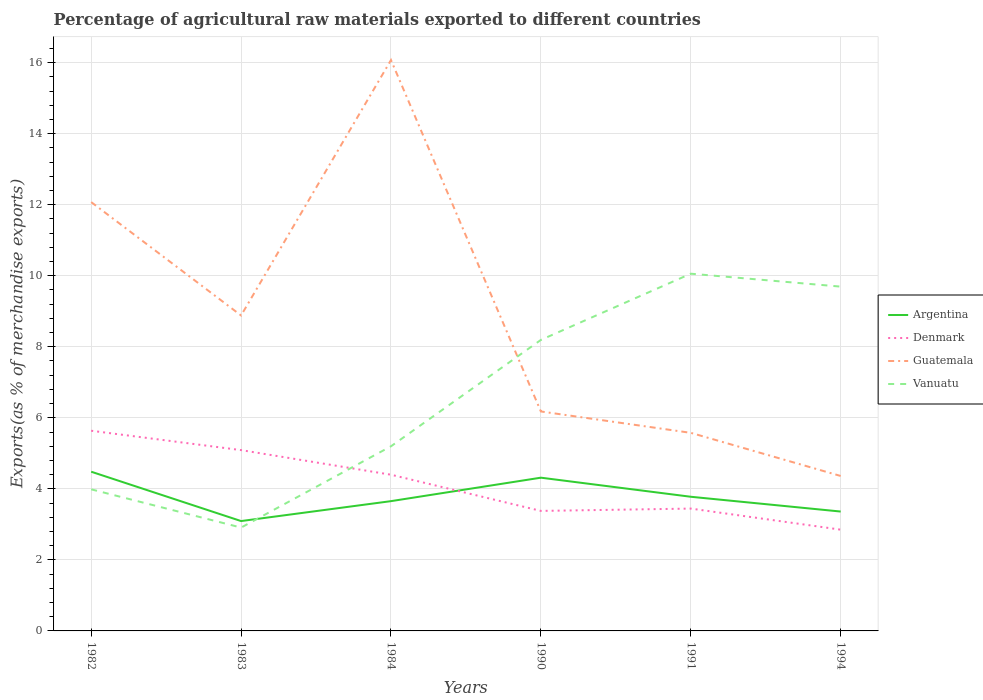How many different coloured lines are there?
Make the answer very short. 4. Does the line corresponding to Guatemala intersect with the line corresponding to Argentina?
Your answer should be very brief. No. Is the number of lines equal to the number of legend labels?
Provide a succinct answer. Yes. Across all years, what is the maximum percentage of exports to different countries in Argentina?
Your answer should be compact. 3.09. What is the total percentage of exports to different countries in Guatemala in the graph?
Offer a terse response. 3.19. What is the difference between the highest and the second highest percentage of exports to different countries in Vanuatu?
Your answer should be compact. 7.15. What is the difference between the highest and the lowest percentage of exports to different countries in Denmark?
Provide a succinct answer. 3. How many lines are there?
Provide a short and direct response. 4. Are the values on the major ticks of Y-axis written in scientific E-notation?
Ensure brevity in your answer.  No. Does the graph contain any zero values?
Offer a very short reply. No. How many legend labels are there?
Provide a short and direct response. 4. How are the legend labels stacked?
Give a very brief answer. Vertical. What is the title of the graph?
Make the answer very short. Percentage of agricultural raw materials exported to different countries. Does "Timor-Leste" appear as one of the legend labels in the graph?
Make the answer very short. No. What is the label or title of the Y-axis?
Provide a succinct answer. Exports(as % of merchandise exports). What is the Exports(as % of merchandise exports) of Argentina in 1982?
Offer a very short reply. 4.48. What is the Exports(as % of merchandise exports) of Denmark in 1982?
Offer a terse response. 5.64. What is the Exports(as % of merchandise exports) in Guatemala in 1982?
Offer a very short reply. 12.07. What is the Exports(as % of merchandise exports) in Vanuatu in 1982?
Provide a succinct answer. 3.99. What is the Exports(as % of merchandise exports) of Argentina in 1983?
Keep it short and to the point. 3.09. What is the Exports(as % of merchandise exports) in Denmark in 1983?
Your answer should be compact. 5.09. What is the Exports(as % of merchandise exports) in Guatemala in 1983?
Your response must be concise. 8.88. What is the Exports(as % of merchandise exports) in Vanuatu in 1983?
Make the answer very short. 2.91. What is the Exports(as % of merchandise exports) in Argentina in 1984?
Make the answer very short. 3.65. What is the Exports(as % of merchandise exports) in Denmark in 1984?
Your response must be concise. 4.4. What is the Exports(as % of merchandise exports) of Guatemala in 1984?
Your answer should be compact. 16.07. What is the Exports(as % of merchandise exports) of Vanuatu in 1984?
Keep it short and to the point. 5.2. What is the Exports(as % of merchandise exports) of Argentina in 1990?
Give a very brief answer. 4.31. What is the Exports(as % of merchandise exports) in Denmark in 1990?
Your answer should be compact. 3.38. What is the Exports(as % of merchandise exports) of Guatemala in 1990?
Your answer should be very brief. 6.18. What is the Exports(as % of merchandise exports) of Vanuatu in 1990?
Your answer should be very brief. 8.19. What is the Exports(as % of merchandise exports) in Argentina in 1991?
Offer a terse response. 3.78. What is the Exports(as % of merchandise exports) of Denmark in 1991?
Give a very brief answer. 3.44. What is the Exports(as % of merchandise exports) of Guatemala in 1991?
Offer a terse response. 5.58. What is the Exports(as % of merchandise exports) in Vanuatu in 1991?
Your response must be concise. 10.06. What is the Exports(as % of merchandise exports) of Argentina in 1994?
Offer a terse response. 3.36. What is the Exports(as % of merchandise exports) in Denmark in 1994?
Offer a very short reply. 2.85. What is the Exports(as % of merchandise exports) in Guatemala in 1994?
Keep it short and to the point. 4.36. What is the Exports(as % of merchandise exports) of Vanuatu in 1994?
Your answer should be compact. 9.69. Across all years, what is the maximum Exports(as % of merchandise exports) in Argentina?
Your answer should be very brief. 4.48. Across all years, what is the maximum Exports(as % of merchandise exports) of Denmark?
Offer a terse response. 5.64. Across all years, what is the maximum Exports(as % of merchandise exports) of Guatemala?
Keep it short and to the point. 16.07. Across all years, what is the maximum Exports(as % of merchandise exports) of Vanuatu?
Your answer should be very brief. 10.06. Across all years, what is the minimum Exports(as % of merchandise exports) of Argentina?
Keep it short and to the point. 3.09. Across all years, what is the minimum Exports(as % of merchandise exports) of Denmark?
Ensure brevity in your answer.  2.85. Across all years, what is the minimum Exports(as % of merchandise exports) of Guatemala?
Make the answer very short. 4.36. Across all years, what is the minimum Exports(as % of merchandise exports) in Vanuatu?
Provide a succinct answer. 2.91. What is the total Exports(as % of merchandise exports) in Argentina in the graph?
Your response must be concise. 22.68. What is the total Exports(as % of merchandise exports) in Denmark in the graph?
Provide a short and direct response. 24.8. What is the total Exports(as % of merchandise exports) of Guatemala in the graph?
Your response must be concise. 53.14. What is the total Exports(as % of merchandise exports) of Vanuatu in the graph?
Give a very brief answer. 40.04. What is the difference between the Exports(as % of merchandise exports) in Argentina in 1982 and that in 1983?
Your answer should be compact. 1.39. What is the difference between the Exports(as % of merchandise exports) in Denmark in 1982 and that in 1983?
Provide a succinct answer. 0.55. What is the difference between the Exports(as % of merchandise exports) in Guatemala in 1982 and that in 1983?
Provide a short and direct response. 3.19. What is the difference between the Exports(as % of merchandise exports) of Vanuatu in 1982 and that in 1983?
Your answer should be very brief. 1.08. What is the difference between the Exports(as % of merchandise exports) of Argentina in 1982 and that in 1984?
Ensure brevity in your answer.  0.83. What is the difference between the Exports(as % of merchandise exports) in Denmark in 1982 and that in 1984?
Provide a succinct answer. 1.24. What is the difference between the Exports(as % of merchandise exports) of Guatemala in 1982 and that in 1984?
Your response must be concise. -4. What is the difference between the Exports(as % of merchandise exports) in Vanuatu in 1982 and that in 1984?
Keep it short and to the point. -1.21. What is the difference between the Exports(as % of merchandise exports) of Argentina in 1982 and that in 1990?
Keep it short and to the point. 0.17. What is the difference between the Exports(as % of merchandise exports) in Denmark in 1982 and that in 1990?
Keep it short and to the point. 2.26. What is the difference between the Exports(as % of merchandise exports) of Guatemala in 1982 and that in 1990?
Your answer should be very brief. 5.89. What is the difference between the Exports(as % of merchandise exports) of Vanuatu in 1982 and that in 1990?
Your answer should be very brief. -4.21. What is the difference between the Exports(as % of merchandise exports) of Argentina in 1982 and that in 1991?
Give a very brief answer. 0.71. What is the difference between the Exports(as % of merchandise exports) in Denmark in 1982 and that in 1991?
Keep it short and to the point. 2.19. What is the difference between the Exports(as % of merchandise exports) in Guatemala in 1982 and that in 1991?
Your answer should be compact. 6.5. What is the difference between the Exports(as % of merchandise exports) in Vanuatu in 1982 and that in 1991?
Provide a succinct answer. -6.07. What is the difference between the Exports(as % of merchandise exports) of Argentina in 1982 and that in 1994?
Provide a short and direct response. 1.12. What is the difference between the Exports(as % of merchandise exports) in Denmark in 1982 and that in 1994?
Your answer should be compact. 2.79. What is the difference between the Exports(as % of merchandise exports) of Guatemala in 1982 and that in 1994?
Your answer should be compact. 7.71. What is the difference between the Exports(as % of merchandise exports) of Vanuatu in 1982 and that in 1994?
Offer a terse response. -5.71. What is the difference between the Exports(as % of merchandise exports) of Argentina in 1983 and that in 1984?
Provide a succinct answer. -0.56. What is the difference between the Exports(as % of merchandise exports) of Denmark in 1983 and that in 1984?
Ensure brevity in your answer.  0.69. What is the difference between the Exports(as % of merchandise exports) of Guatemala in 1983 and that in 1984?
Provide a succinct answer. -7.19. What is the difference between the Exports(as % of merchandise exports) of Vanuatu in 1983 and that in 1984?
Provide a short and direct response. -2.29. What is the difference between the Exports(as % of merchandise exports) in Argentina in 1983 and that in 1990?
Your response must be concise. -1.22. What is the difference between the Exports(as % of merchandise exports) of Denmark in 1983 and that in 1990?
Your answer should be compact. 1.71. What is the difference between the Exports(as % of merchandise exports) of Guatemala in 1983 and that in 1990?
Your answer should be compact. 2.7. What is the difference between the Exports(as % of merchandise exports) of Vanuatu in 1983 and that in 1990?
Your response must be concise. -5.28. What is the difference between the Exports(as % of merchandise exports) in Argentina in 1983 and that in 1991?
Your response must be concise. -0.68. What is the difference between the Exports(as % of merchandise exports) in Denmark in 1983 and that in 1991?
Make the answer very short. 1.65. What is the difference between the Exports(as % of merchandise exports) of Guatemala in 1983 and that in 1991?
Keep it short and to the point. 3.3. What is the difference between the Exports(as % of merchandise exports) of Vanuatu in 1983 and that in 1991?
Make the answer very short. -7.15. What is the difference between the Exports(as % of merchandise exports) of Argentina in 1983 and that in 1994?
Your response must be concise. -0.27. What is the difference between the Exports(as % of merchandise exports) in Denmark in 1983 and that in 1994?
Offer a very short reply. 2.24. What is the difference between the Exports(as % of merchandise exports) in Guatemala in 1983 and that in 1994?
Make the answer very short. 4.52. What is the difference between the Exports(as % of merchandise exports) of Vanuatu in 1983 and that in 1994?
Your response must be concise. -6.78. What is the difference between the Exports(as % of merchandise exports) of Argentina in 1984 and that in 1990?
Provide a succinct answer. -0.66. What is the difference between the Exports(as % of merchandise exports) of Denmark in 1984 and that in 1990?
Offer a very short reply. 1.02. What is the difference between the Exports(as % of merchandise exports) in Guatemala in 1984 and that in 1990?
Provide a succinct answer. 9.89. What is the difference between the Exports(as % of merchandise exports) in Vanuatu in 1984 and that in 1990?
Provide a succinct answer. -2.99. What is the difference between the Exports(as % of merchandise exports) of Argentina in 1984 and that in 1991?
Your response must be concise. -0.12. What is the difference between the Exports(as % of merchandise exports) in Denmark in 1984 and that in 1991?
Offer a very short reply. 0.95. What is the difference between the Exports(as % of merchandise exports) in Guatemala in 1984 and that in 1991?
Your answer should be compact. 10.49. What is the difference between the Exports(as % of merchandise exports) of Vanuatu in 1984 and that in 1991?
Provide a short and direct response. -4.86. What is the difference between the Exports(as % of merchandise exports) in Argentina in 1984 and that in 1994?
Offer a terse response. 0.29. What is the difference between the Exports(as % of merchandise exports) in Denmark in 1984 and that in 1994?
Provide a short and direct response. 1.55. What is the difference between the Exports(as % of merchandise exports) of Guatemala in 1984 and that in 1994?
Make the answer very short. 11.71. What is the difference between the Exports(as % of merchandise exports) of Vanuatu in 1984 and that in 1994?
Ensure brevity in your answer.  -4.5. What is the difference between the Exports(as % of merchandise exports) in Argentina in 1990 and that in 1991?
Keep it short and to the point. 0.54. What is the difference between the Exports(as % of merchandise exports) of Denmark in 1990 and that in 1991?
Keep it short and to the point. -0.07. What is the difference between the Exports(as % of merchandise exports) in Guatemala in 1990 and that in 1991?
Provide a short and direct response. 0.6. What is the difference between the Exports(as % of merchandise exports) of Vanuatu in 1990 and that in 1991?
Offer a terse response. -1.86. What is the difference between the Exports(as % of merchandise exports) in Argentina in 1990 and that in 1994?
Your response must be concise. 0.95. What is the difference between the Exports(as % of merchandise exports) in Denmark in 1990 and that in 1994?
Ensure brevity in your answer.  0.53. What is the difference between the Exports(as % of merchandise exports) of Guatemala in 1990 and that in 1994?
Your answer should be compact. 1.82. What is the difference between the Exports(as % of merchandise exports) of Vanuatu in 1990 and that in 1994?
Ensure brevity in your answer.  -1.5. What is the difference between the Exports(as % of merchandise exports) in Argentina in 1991 and that in 1994?
Provide a succinct answer. 0.42. What is the difference between the Exports(as % of merchandise exports) in Denmark in 1991 and that in 1994?
Give a very brief answer. 0.59. What is the difference between the Exports(as % of merchandise exports) in Guatemala in 1991 and that in 1994?
Provide a succinct answer. 1.21. What is the difference between the Exports(as % of merchandise exports) in Vanuatu in 1991 and that in 1994?
Provide a succinct answer. 0.36. What is the difference between the Exports(as % of merchandise exports) in Argentina in 1982 and the Exports(as % of merchandise exports) in Denmark in 1983?
Give a very brief answer. -0.61. What is the difference between the Exports(as % of merchandise exports) in Argentina in 1982 and the Exports(as % of merchandise exports) in Guatemala in 1983?
Keep it short and to the point. -4.4. What is the difference between the Exports(as % of merchandise exports) of Argentina in 1982 and the Exports(as % of merchandise exports) of Vanuatu in 1983?
Make the answer very short. 1.57. What is the difference between the Exports(as % of merchandise exports) in Denmark in 1982 and the Exports(as % of merchandise exports) in Guatemala in 1983?
Keep it short and to the point. -3.25. What is the difference between the Exports(as % of merchandise exports) of Denmark in 1982 and the Exports(as % of merchandise exports) of Vanuatu in 1983?
Your answer should be very brief. 2.73. What is the difference between the Exports(as % of merchandise exports) of Guatemala in 1982 and the Exports(as % of merchandise exports) of Vanuatu in 1983?
Your answer should be very brief. 9.16. What is the difference between the Exports(as % of merchandise exports) in Argentina in 1982 and the Exports(as % of merchandise exports) in Denmark in 1984?
Ensure brevity in your answer.  0.08. What is the difference between the Exports(as % of merchandise exports) of Argentina in 1982 and the Exports(as % of merchandise exports) of Guatemala in 1984?
Give a very brief answer. -11.59. What is the difference between the Exports(as % of merchandise exports) of Argentina in 1982 and the Exports(as % of merchandise exports) of Vanuatu in 1984?
Provide a succinct answer. -0.72. What is the difference between the Exports(as % of merchandise exports) in Denmark in 1982 and the Exports(as % of merchandise exports) in Guatemala in 1984?
Give a very brief answer. -10.44. What is the difference between the Exports(as % of merchandise exports) of Denmark in 1982 and the Exports(as % of merchandise exports) of Vanuatu in 1984?
Offer a very short reply. 0.44. What is the difference between the Exports(as % of merchandise exports) in Guatemala in 1982 and the Exports(as % of merchandise exports) in Vanuatu in 1984?
Give a very brief answer. 6.87. What is the difference between the Exports(as % of merchandise exports) of Argentina in 1982 and the Exports(as % of merchandise exports) of Denmark in 1990?
Provide a short and direct response. 1.1. What is the difference between the Exports(as % of merchandise exports) of Argentina in 1982 and the Exports(as % of merchandise exports) of Guatemala in 1990?
Your response must be concise. -1.7. What is the difference between the Exports(as % of merchandise exports) in Argentina in 1982 and the Exports(as % of merchandise exports) in Vanuatu in 1990?
Provide a succinct answer. -3.71. What is the difference between the Exports(as % of merchandise exports) in Denmark in 1982 and the Exports(as % of merchandise exports) in Guatemala in 1990?
Keep it short and to the point. -0.54. What is the difference between the Exports(as % of merchandise exports) of Denmark in 1982 and the Exports(as % of merchandise exports) of Vanuatu in 1990?
Give a very brief answer. -2.56. What is the difference between the Exports(as % of merchandise exports) of Guatemala in 1982 and the Exports(as % of merchandise exports) of Vanuatu in 1990?
Give a very brief answer. 3.88. What is the difference between the Exports(as % of merchandise exports) in Argentina in 1982 and the Exports(as % of merchandise exports) in Denmark in 1991?
Keep it short and to the point. 1.04. What is the difference between the Exports(as % of merchandise exports) in Argentina in 1982 and the Exports(as % of merchandise exports) in Guatemala in 1991?
Your answer should be very brief. -1.09. What is the difference between the Exports(as % of merchandise exports) in Argentina in 1982 and the Exports(as % of merchandise exports) in Vanuatu in 1991?
Your answer should be compact. -5.57. What is the difference between the Exports(as % of merchandise exports) in Denmark in 1982 and the Exports(as % of merchandise exports) in Guatemala in 1991?
Make the answer very short. 0.06. What is the difference between the Exports(as % of merchandise exports) in Denmark in 1982 and the Exports(as % of merchandise exports) in Vanuatu in 1991?
Your answer should be very brief. -4.42. What is the difference between the Exports(as % of merchandise exports) of Guatemala in 1982 and the Exports(as % of merchandise exports) of Vanuatu in 1991?
Provide a short and direct response. 2.02. What is the difference between the Exports(as % of merchandise exports) in Argentina in 1982 and the Exports(as % of merchandise exports) in Denmark in 1994?
Ensure brevity in your answer.  1.63. What is the difference between the Exports(as % of merchandise exports) in Argentina in 1982 and the Exports(as % of merchandise exports) in Guatemala in 1994?
Your answer should be compact. 0.12. What is the difference between the Exports(as % of merchandise exports) of Argentina in 1982 and the Exports(as % of merchandise exports) of Vanuatu in 1994?
Your response must be concise. -5.21. What is the difference between the Exports(as % of merchandise exports) of Denmark in 1982 and the Exports(as % of merchandise exports) of Guatemala in 1994?
Your response must be concise. 1.27. What is the difference between the Exports(as % of merchandise exports) in Denmark in 1982 and the Exports(as % of merchandise exports) in Vanuatu in 1994?
Your answer should be very brief. -4.06. What is the difference between the Exports(as % of merchandise exports) in Guatemala in 1982 and the Exports(as % of merchandise exports) in Vanuatu in 1994?
Offer a very short reply. 2.38. What is the difference between the Exports(as % of merchandise exports) in Argentina in 1983 and the Exports(as % of merchandise exports) in Denmark in 1984?
Your answer should be very brief. -1.3. What is the difference between the Exports(as % of merchandise exports) in Argentina in 1983 and the Exports(as % of merchandise exports) in Guatemala in 1984?
Offer a very short reply. -12.98. What is the difference between the Exports(as % of merchandise exports) in Argentina in 1983 and the Exports(as % of merchandise exports) in Vanuatu in 1984?
Ensure brevity in your answer.  -2.1. What is the difference between the Exports(as % of merchandise exports) in Denmark in 1983 and the Exports(as % of merchandise exports) in Guatemala in 1984?
Provide a short and direct response. -10.98. What is the difference between the Exports(as % of merchandise exports) in Denmark in 1983 and the Exports(as % of merchandise exports) in Vanuatu in 1984?
Give a very brief answer. -0.11. What is the difference between the Exports(as % of merchandise exports) in Guatemala in 1983 and the Exports(as % of merchandise exports) in Vanuatu in 1984?
Make the answer very short. 3.68. What is the difference between the Exports(as % of merchandise exports) in Argentina in 1983 and the Exports(as % of merchandise exports) in Denmark in 1990?
Offer a very short reply. -0.29. What is the difference between the Exports(as % of merchandise exports) of Argentina in 1983 and the Exports(as % of merchandise exports) of Guatemala in 1990?
Keep it short and to the point. -3.09. What is the difference between the Exports(as % of merchandise exports) in Argentina in 1983 and the Exports(as % of merchandise exports) in Vanuatu in 1990?
Provide a short and direct response. -5.1. What is the difference between the Exports(as % of merchandise exports) of Denmark in 1983 and the Exports(as % of merchandise exports) of Guatemala in 1990?
Your answer should be compact. -1.09. What is the difference between the Exports(as % of merchandise exports) in Denmark in 1983 and the Exports(as % of merchandise exports) in Vanuatu in 1990?
Offer a terse response. -3.1. What is the difference between the Exports(as % of merchandise exports) in Guatemala in 1983 and the Exports(as % of merchandise exports) in Vanuatu in 1990?
Keep it short and to the point. 0.69. What is the difference between the Exports(as % of merchandise exports) in Argentina in 1983 and the Exports(as % of merchandise exports) in Denmark in 1991?
Provide a short and direct response. -0.35. What is the difference between the Exports(as % of merchandise exports) in Argentina in 1983 and the Exports(as % of merchandise exports) in Guatemala in 1991?
Keep it short and to the point. -2.48. What is the difference between the Exports(as % of merchandise exports) in Argentina in 1983 and the Exports(as % of merchandise exports) in Vanuatu in 1991?
Your answer should be very brief. -6.96. What is the difference between the Exports(as % of merchandise exports) of Denmark in 1983 and the Exports(as % of merchandise exports) of Guatemala in 1991?
Provide a succinct answer. -0.49. What is the difference between the Exports(as % of merchandise exports) in Denmark in 1983 and the Exports(as % of merchandise exports) in Vanuatu in 1991?
Ensure brevity in your answer.  -4.97. What is the difference between the Exports(as % of merchandise exports) in Guatemala in 1983 and the Exports(as % of merchandise exports) in Vanuatu in 1991?
Your response must be concise. -1.18. What is the difference between the Exports(as % of merchandise exports) in Argentina in 1983 and the Exports(as % of merchandise exports) in Denmark in 1994?
Keep it short and to the point. 0.24. What is the difference between the Exports(as % of merchandise exports) of Argentina in 1983 and the Exports(as % of merchandise exports) of Guatemala in 1994?
Offer a very short reply. -1.27. What is the difference between the Exports(as % of merchandise exports) in Argentina in 1983 and the Exports(as % of merchandise exports) in Vanuatu in 1994?
Offer a very short reply. -6.6. What is the difference between the Exports(as % of merchandise exports) of Denmark in 1983 and the Exports(as % of merchandise exports) of Guatemala in 1994?
Provide a succinct answer. 0.73. What is the difference between the Exports(as % of merchandise exports) in Denmark in 1983 and the Exports(as % of merchandise exports) in Vanuatu in 1994?
Offer a terse response. -4.6. What is the difference between the Exports(as % of merchandise exports) of Guatemala in 1983 and the Exports(as % of merchandise exports) of Vanuatu in 1994?
Your response must be concise. -0.81. What is the difference between the Exports(as % of merchandise exports) of Argentina in 1984 and the Exports(as % of merchandise exports) of Denmark in 1990?
Give a very brief answer. 0.28. What is the difference between the Exports(as % of merchandise exports) in Argentina in 1984 and the Exports(as % of merchandise exports) in Guatemala in 1990?
Offer a terse response. -2.52. What is the difference between the Exports(as % of merchandise exports) of Argentina in 1984 and the Exports(as % of merchandise exports) of Vanuatu in 1990?
Offer a very short reply. -4.54. What is the difference between the Exports(as % of merchandise exports) in Denmark in 1984 and the Exports(as % of merchandise exports) in Guatemala in 1990?
Give a very brief answer. -1.78. What is the difference between the Exports(as % of merchandise exports) in Denmark in 1984 and the Exports(as % of merchandise exports) in Vanuatu in 1990?
Your answer should be compact. -3.8. What is the difference between the Exports(as % of merchandise exports) of Guatemala in 1984 and the Exports(as % of merchandise exports) of Vanuatu in 1990?
Your answer should be compact. 7.88. What is the difference between the Exports(as % of merchandise exports) in Argentina in 1984 and the Exports(as % of merchandise exports) in Denmark in 1991?
Make the answer very short. 0.21. What is the difference between the Exports(as % of merchandise exports) in Argentina in 1984 and the Exports(as % of merchandise exports) in Guatemala in 1991?
Offer a very short reply. -1.92. What is the difference between the Exports(as % of merchandise exports) in Argentina in 1984 and the Exports(as % of merchandise exports) in Vanuatu in 1991?
Your answer should be very brief. -6.4. What is the difference between the Exports(as % of merchandise exports) of Denmark in 1984 and the Exports(as % of merchandise exports) of Guatemala in 1991?
Your answer should be compact. -1.18. What is the difference between the Exports(as % of merchandise exports) in Denmark in 1984 and the Exports(as % of merchandise exports) in Vanuatu in 1991?
Offer a very short reply. -5.66. What is the difference between the Exports(as % of merchandise exports) of Guatemala in 1984 and the Exports(as % of merchandise exports) of Vanuatu in 1991?
Provide a succinct answer. 6.01. What is the difference between the Exports(as % of merchandise exports) in Argentina in 1984 and the Exports(as % of merchandise exports) in Denmark in 1994?
Provide a succinct answer. 0.8. What is the difference between the Exports(as % of merchandise exports) in Argentina in 1984 and the Exports(as % of merchandise exports) in Guatemala in 1994?
Ensure brevity in your answer.  -0.71. What is the difference between the Exports(as % of merchandise exports) in Argentina in 1984 and the Exports(as % of merchandise exports) in Vanuatu in 1994?
Provide a succinct answer. -6.04. What is the difference between the Exports(as % of merchandise exports) of Denmark in 1984 and the Exports(as % of merchandise exports) of Guatemala in 1994?
Provide a succinct answer. 0.04. What is the difference between the Exports(as % of merchandise exports) of Denmark in 1984 and the Exports(as % of merchandise exports) of Vanuatu in 1994?
Offer a terse response. -5.3. What is the difference between the Exports(as % of merchandise exports) in Guatemala in 1984 and the Exports(as % of merchandise exports) in Vanuatu in 1994?
Keep it short and to the point. 6.38. What is the difference between the Exports(as % of merchandise exports) in Argentina in 1990 and the Exports(as % of merchandise exports) in Denmark in 1991?
Keep it short and to the point. 0.87. What is the difference between the Exports(as % of merchandise exports) in Argentina in 1990 and the Exports(as % of merchandise exports) in Guatemala in 1991?
Your response must be concise. -1.26. What is the difference between the Exports(as % of merchandise exports) in Argentina in 1990 and the Exports(as % of merchandise exports) in Vanuatu in 1991?
Offer a terse response. -5.74. What is the difference between the Exports(as % of merchandise exports) of Denmark in 1990 and the Exports(as % of merchandise exports) of Guatemala in 1991?
Your answer should be very brief. -2.2. What is the difference between the Exports(as % of merchandise exports) in Denmark in 1990 and the Exports(as % of merchandise exports) in Vanuatu in 1991?
Your answer should be very brief. -6.68. What is the difference between the Exports(as % of merchandise exports) of Guatemala in 1990 and the Exports(as % of merchandise exports) of Vanuatu in 1991?
Make the answer very short. -3.88. What is the difference between the Exports(as % of merchandise exports) in Argentina in 1990 and the Exports(as % of merchandise exports) in Denmark in 1994?
Ensure brevity in your answer.  1.46. What is the difference between the Exports(as % of merchandise exports) in Argentina in 1990 and the Exports(as % of merchandise exports) in Guatemala in 1994?
Your answer should be compact. -0.05. What is the difference between the Exports(as % of merchandise exports) in Argentina in 1990 and the Exports(as % of merchandise exports) in Vanuatu in 1994?
Give a very brief answer. -5.38. What is the difference between the Exports(as % of merchandise exports) of Denmark in 1990 and the Exports(as % of merchandise exports) of Guatemala in 1994?
Provide a succinct answer. -0.98. What is the difference between the Exports(as % of merchandise exports) in Denmark in 1990 and the Exports(as % of merchandise exports) in Vanuatu in 1994?
Provide a short and direct response. -6.31. What is the difference between the Exports(as % of merchandise exports) in Guatemala in 1990 and the Exports(as % of merchandise exports) in Vanuatu in 1994?
Provide a short and direct response. -3.52. What is the difference between the Exports(as % of merchandise exports) in Argentina in 1991 and the Exports(as % of merchandise exports) in Denmark in 1994?
Offer a very short reply. 0.93. What is the difference between the Exports(as % of merchandise exports) of Argentina in 1991 and the Exports(as % of merchandise exports) of Guatemala in 1994?
Ensure brevity in your answer.  -0.59. What is the difference between the Exports(as % of merchandise exports) of Argentina in 1991 and the Exports(as % of merchandise exports) of Vanuatu in 1994?
Make the answer very short. -5.92. What is the difference between the Exports(as % of merchandise exports) of Denmark in 1991 and the Exports(as % of merchandise exports) of Guatemala in 1994?
Offer a terse response. -0.92. What is the difference between the Exports(as % of merchandise exports) in Denmark in 1991 and the Exports(as % of merchandise exports) in Vanuatu in 1994?
Offer a very short reply. -6.25. What is the difference between the Exports(as % of merchandise exports) of Guatemala in 1991 and the Exports(as % of merchandise exports) of Vanuatu in 1994?
Your answer should be very brief. -4.12. What is the average Exports(as % of merchandise exports) in Argentina per year?
Your response must be concise. 3.78. What is the average Exports(as % of merchandise exports) in Denmark per year?
Your answer should be compact. 4.13. What is the average Exports(as % of merchandise exports) in Guatemala per year?
Give a very brief answer. 8.86. What is the average Exports(as % of merchandise exports) in Vanuatu per year?
Provide a succinct answer. 6.67. In the year 1982, what is the difference between the Exports(as % of merchandise exports) of Argentina and Exports(as % of merchandise exports) of Denmark?
Make the answer very short. -1.15. In the year 1982, what is the difference between the Exports(as % of merchandise exports) of Argentina and Exports(as % of merchandise exports) of Guatemala?
Your response must be concise. -7.59. In the year 1982, what is the difference between the Exports(as % of merchandise exports) in Argentina and Exports(as % of merchandise exports) in Vanuatu?
Your response must be concise. 0.5. In the year 1982, what is the difference between the Exports(as % of merchandise exports) in Denmark and Exports(as % of merchandise exports) in Guatemala?
Your response must be concise. -6.44. In the year 1982, what is the difference between the Exports(as % of merchandise exports) in Denmark and Exports(as % of merchandise exports) in Vanuatu?
Ensure brevity in your answer.  1.65. In the year 1982, what is the difference between the Exports(as % of merchandise exports) of Guatemala and Exports(as % of merchandise exports) of Vanuatu?
Ensure brevity in your answer.  8.09. In the year 1983, what is the difference between the Exports(as % of merchandise exports) in Argentina and Exports(as % of merchandise exports) in Denmark?
Offer a very short reply. -2. In the year 1983, what is the difference between the Exports(as % of merchandise exports) in Argentina and Exports(as % of merchandise exports) in Guatemala?
Provide a short and direct response. -5.79. In the year 1983, what is the difference between the Exports(as % of merchandise exports) in Argentina and Exports(as % of merchandise exports) in Vanuatu?
Offer a terse response. 0.18. In the year 1983, what is the difference between the Exports(as % of merchandise exports) of Denmark and Exports(as % of merchandise exports) of Guatemala?
Offer a very short reply. -3.79. In the year 1983, what is the difference between the Exports(as % of merchandise exports) of Denmark and Exports(as % of merchandise exports) of Vanuatu?
Your response must be concise. 2.18. In the year 1983, what is the difference between the Exports(as % of merchandise exports) in Guatemala and Exports(as % of merchandise exports) in Vanuatu?
Provide a short and direct response. 5.97. In the year 1984, what is the difference between the Exports(as % of merchandise exports) in Argentina and Exports(as % of merchandise exports) in Denmark?
Provide a short and direct response. -0.74. In the year 1984, what is the difference between the Exports(as % of merchandise exports) of Argentina and Exports(as % of merchandise exports) of Guatemala?
Offer a very short reply. -12.42. In the year 1984, what is the difference between the Exports(as % of merchandise exports) of Argentina and Exports(as % of merchandise exports) of Vanuatu?
Provide a succinct answer. -1.54. In the year 1984, what is the difference between the Exports(as % of merchandise exports) of Denmark and Exports(as % of merchandise exports) of Guatemala?
Offer a very short reply. -11.67. In the year 1984, what is the difference between the Exports(as % of merchandise exports) of Denmark and Exports(as % of merchandise exports) of Vanuatu?
Your response must be concise. -0.8. In the year 1984, what is the difference between the Exports(as % of merchandise exports) of Guatemala and Exports(as % of merchandise exports) of Vanuatu?
Provide a succinct answer. 10.87. In the year 1990, what is the difference between the Exports(as % of merchandise exports) of Argentina and Exports(as % of merchandise exports) of Denmark?
Provide a short and direct response. 0.94. In the year 1990, what is the difference between the Exports(as % of merchandise exports) of Argentina and Exports(as % of merchandise exports) of Guatemala?
Provide a succinct answer. -1.86. In the year 1990, what is the difference between the Exports(as % of merchandise exports) of Argentina and Exports(as % of merchandise exports) of Vanuatu?
Offer a terse response. -3.88. In the year 1990, what is the difference between the Exports(as % of merchandise exports) in Denmark and Exports(as % of merchandise exports) in Guatemala?
Offer a very short reply. -2.8. In the year 1990, what is the difference between the Exports(as % of merchandise exports) of Denmark and Exports(as % of merchandise exports) of Vanuatu?
Give a very brief answer. -4.81. In the year 1990, what is the difference between the Exports(as % of merchandise exports) of Guatemala and Exports(as % of merchandise exports) of Vanuatu?
Keep it short and to the point. -2.01. In the year 1991, what is the difference between the Exports(as % of merchandise exports) in Argentina and Exports(as % of merchandise exports) in Denmark?
Make the answer very short. 0.33. In the year 1991, what is the difference between the Exports(as % of merchandise exports) in Argentina and Exports(as % of merchandise exports) in Guatemala?
Keep it short and to the point. -1.8. In the year 1991, what is the difference between the Exports(as % of merchandise exports) of Argentina and Exports(as % of merchandise exports) of Vanuatu?
Give a very brief answer. -6.28. In the year 1991, what is the difference between the Exports(as % of merchandise exports) of Denmark and Exports(as % of merchandise exports) of Guatemala?
Offer a terse response. -2.13. In the year 1991, what is the difference between the Exports(as % of merchandise exports) in Denmark and Exports(as % of merchandise exports) in Vanuatu?
Give a very brief answer. -6.61. In the year 1991, what is the difference between the Exports(as % of merchandise exports) in Guatemala and Exports(as % of merchandise exports) in Vanuatu?
Provide a short and direct response. -4.48. In the year 1994, what is the difference between the Exports(as % of merchandise exports) in Argentina and Exports(as % of merchandise exports) in Denmark?
Offer a terse response. 0.51. In the year 1994, what is the difference between the Exports(as % of merchandise exports) of Argentina and Exports(as % of merchandise exports) of Guatemala?
Give a very brief answer. -1. In the year 1994, what is the difference between the Exports(as % of merchandise exports) of Argentina and Exports(as % of merchandise exports) of Vanuatu?
Provide a succinct answer. -6.33. In the year 1994, what is the difference between the Exports(as % of merchandise exports) in Denmark and Exports(as % of merchandise exports) in Guatemala?
Provide a succinct answer. -1.51. In the year 1994, what is the difference between the Exports(as % of merchandise exports) in Denmark and Exports(as % of merchandise exports) in Vanuatu?
Your answer should be very brief. -6.84. In the year 1994, what is the difference between the Exports(as % of merchandise exports) in Guatemala and Exports(as % of merchandise exports) in Vanuatu?
Offer a very short reply. -5.33. What is the ratio of the Exports(as % of merchandise exports) in Argentina in 1982 to that in 1983?
Your answer should be compact. 1.45. What is the ratio of the Exports(as % of merchandise exports) in Denmark in 1982 to that in 1983?
Give a very brief answer. 1.11. What is the ratio of the Exports(as % of merchandise exports) of Guatemala in 1982 to that in 1983?
Your response must be concise. 1.36. What is the ratio of the Exports(as % of merchandise exports) of Vanuatu in 1982 to that in 1983?
Give a very brief answer. 1.37. What is the ratio of the Exports(as % of merchandise exports) of Argentina in 1982 to that in 1984?
Your response must be concise. 1.23. What is the ratio of the Exports(as % of merchandise exports) of Denmark in 1982 to that in 1984?
Provide a short and direct response. 1.28. What is the ratio of the Exports(as % of merchandise exports) of Guatemala in 1982 to that in 1984?
Your response must be concise. 0.75. What is the ratio of the Exports(as % of merchandise exports) of Vanuatu in 1982 to that in 1984?
Provide a short and direct response. 0.77. What is the ratio of the Exports(as % of merchandise exports) of Argentina in 1982 to that in 1990?
Make the answer very short. 1.04. What is the ratio of the Exports(as % of merchandise exports) of Denmark in 1982 to that in 1990?
Your answer should be compact. 1.67. What is the ratio of the Exports(as % of merchandise exports) in Guatemala in 1982 to that in 1990?
Your answer should be very brief. 1.95. What is the ratio of the Exports(as % of merchandise exports) in Vanuatu in 1982 to that in 1990?
Make the answer very short. 0.49. What is the ratio of the Exports(as % of merchandise exports) in Argentina in 1982 to that in 1991?
Provide a succinct answer. 1.19. What is the ratio of the Exports(as % of merchandise exports) of Denmark in 1982 to that in 1991?
Offer a terse response. 1.64. What is the ratio of the Exports(as % of merchandise exports) of Guatemala in 1982 to that in 1991?
Offer a terse response. 2.16. What is the ratio of the Exports(as % of merchandise exports) in Vanuatu in 1982 to that in 1991?
Offer a very short reply. 0.4. What is the ratio of the Exports(as % of merchandise exports) in Argentina in 1982 to that in 1994?
Provide a short and direct response. 1.33. What is the ratio of the Exports(as % of merchandise exports) of Denmark in 1982 to that in 1994?
Make the answer very short. 1.98. What is the ratio of the Exports(as % of merchandise exports) of Guatemala in 1982 to that in 1994?
Your response must be concise. 2.77. What is the ratio of the Exports(as % of merchandise exports) in Vanuatu in 1982 to that in 1994?
Ensure brevity in your answer.  0.41. What is the ratio of the Exports(as % of merchandise exports) of Argentina in 1983 to that in 1984?
Make the answer very short. 0.85. What is the ratio of the Exports(as % of merchandise exports) in Denmark in 1983 to that in 1984?
Your answer should be very brief. 1.16. What is the ratio of the Exports(as % of merchandise exports) of Guatemala in 1983 to that in 1984?
Provide a succinct answer. 0.55. What is the ratio of the Exports(as % of merchandise exports) in Vanuatu in 1983 to that in 1984?
Offer a terse response. 0.56. What is the ratio of the Exports(as % of merchandise exports) in Argentina in 1983 to that in 1990?
Provide a succinct answer. 0.72. What is the ratio of the Exports(as % of merchandise exports) of Denmark in 1983 to that in 1990?
Provide a short and direct response. 1.51. What is the ratio of the Exports(as % of merchandise exports) of Guatemala in 1983 to that in 1990?
Offer a terse response. 1.44. What is the ratio of the Exports(as % of merchandise exports) of Vanuatu in 1983 to that in 1990?
Provide a short and direct response. 0.36. What is the ratio of the Exports(as % of merchandise exports) of Argentina in 1983 to that in 1991?
Keep it short and to the point. 0.82. What is the ratio of the Exports(as % of merchandise exports) in Denmark in 1983 to that in 1991?
Your answer should be compact. 1.48. What is the ratio of the Exports(as % of merchandise exports) of Guatemala in 1983 to that in 1991?
Your answer should be very brief. 1.59. What is the ratio of the Exports(as % of merchandise exports) in Vanuatu in 1983 to that in 1991?
Offer a very short reply. 0.29. What is the ratio of the Exports(as % of merchandise exports) in Argentina in 1983 to that in 1994?
Your response must be concise. 0.92. What is the ratio of the Exports(as % of merchandise exports) of Denmark in 1983 to that in 1994?
Keep it short and to the point. 1.79. What is the ratio of the Exports(as % of merchandise exports) of Guatemala in 1983 to that in 1994?
Ensure brevity in your answer.  2.04. What is the ratio of the Exports(as % of merchandise exports) of Vanuatu in 1983 to that in 1994?
Ensure brevity in your answer.  0.3. What is the ratio of the Exports(as % of merchandise exports) of Argentina in 1984 to that in 1990?
Keep it short and to the point. 0.85. What is the ratio of the Exports(as % of merchandise exports) of Denmark in 1984 to that in 1990?
Offer a very short reply. 1.3. What is the ratio of the Exports(as % of merchandise exports) of Guatemala in 1984 to that in 1990?
Make the answer very short. 2.6. What is the ratio of the Exports(as % of merchandise exports) of Vanuatu in 1984 to that in 1990?
Your answer should be compact. 0.63. What is the ratio of the Exports(as % of merchandise exports) of Argentina in 1984 to that in 1991?
Your answer should be very brief. 0.97. What is the ratio of the Exports(as % of merchandise exports) in Denmark in 1984 to that in 1991?
Offer a very short reply. 1.28. What is the ratio of the Exports(as % of merchandise exports) of Guatemala in 1984 to that in 1991?
Your answer should be very brief. 2.88. What is the ratio of the Exports(as % of merchandise exports) of Vanuatu in 1984 to that in 1991?
Your response must be concise. 0.52. What is the ratio of the Exports(as % of merchandise exports) in Argentina in 1984 to that in 1994?
Give a very brief answer. 1.09. What is the ratio of the Exports(as % of merchandise exports) in Denmark in 1984 to that in 1994?
Your response must be concise. 1.54. What is the ratio of the Exports(as % of merchandise exports) in Guatemala in 1984 to that in 1994?
Ensure brevity in your answer.  3.68. What is the ratio of the Exports(as % of merchandise exports) of Vanuatu in 1984 to that in 1994?
Offer a very short reply. 0.54. What is the ratio of the Exports(as % of merchandise exports) of Argentina in 1990 to that in 1991?
Provide a short and direct response. 1.14. What is the ratio of the Exports(as % of merchandise exports) of Denmark in 1990 to that in 1991?
Your response must be concise. 0.98. What is the ratio of the Exports(as % of merchandise exports) of Guatemala in 1990 to that in 1991?
Offer a very short reply. 1.11. What is the ratio of the Exports(as % of merchandise exports) of Vanuatu in 1990 to that in 1991?
Give a very brief answer. 0.81. What is the ratio of the Exports(as % of merchandise exports) of Argentina in 1990 to that in 1994?
Ensure brevity in your answer.  1.28. What is the ratio of the Exports(as % of merchandise exports) in Denmark in 1990 to that in 1994?
Give a very brief answer. 1.19. What is the ratio of the Exports(as % of merchandise exports) of Guatemala in 1990 to that in 1994?
Provide a succinct answer. 1.42. What is the ratio of the Exports(as % of merchandise exports) in Vanuatu in 1990 to that in 1994?
Your answer should be very brief. 0.85. What is the ratio of the Exports(as % of merchandise exports) of Argentina in 1991 to that in 1994?
Offer a terse response. 1.12. What is the ratio of the Exports(as % of merchandise exports) of Denmark in 1991 to that in 1994?
Offer a terse response. 1.21. What is the ratio of the Exports(as % of merchandise exports) of Guatemala in 1991 to that in 1994?
Your answer should be very brief. 1.28. What is the ratio of the Exports(as % of merchandise exports) in Vanuatu in 1991 to that in 1994?
Your answer should be very brief. 1.04. What is the difference between the highest and the second highest Exports(as % of merchandise exports) of Argentina?
Your answer should be compact. 0.17. What is the difference between the highest and the second highest Exports(as % of merchandise exports) of Denmark?
Your answer should be very brief. 0.55. What is the difference between the highest and the second highest Exports(as % of merchandise exports) in Guatemala?
Make the answer very short. 4. What is the difference between the highest and the second highest Exports(as % of merchandise exports) in Vanuatu?
Keep it short and to the point. 0.36. What is the difference between the highest and the lowest Exports(as % of merchandise exports) in Argentina?
Offer a terse response. 1.39. What is the difference between the highest and the lowest Exports(as % of merchandise exports) in Denmark?
Offer a terse response. 2.79. What is the difference between the highest and the lowest Exports(as % of merchandise exports) of Guatemala?
Keep it short and to the point. 11.71. What is the difference between the highest and the lowest Exports(as % of merchandise exports) in Vanuatu?
Offer a very short reply. 7.15. 